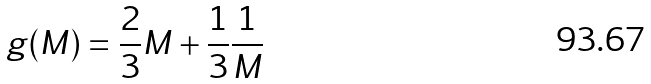<formula> <loc_0><loc_0><loc_500><loc_500>g ( M ) = \frac { 2 } { 3 } M + \frac { 1 } { 3 } \frac { 1 } { M }</formula> 